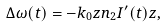<formula> <loc_0><loc_0><loc_500><loc_500>\Delta \omega ( t ) = - k _ { 0 } z n _ { 2 } I ^ { \prime } ( t ) z ,</formula> 